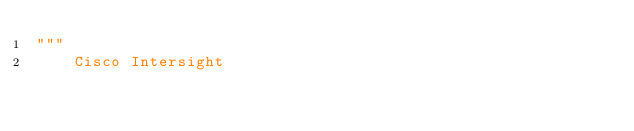<code> <loc_0><loc_0><loc_500><loc_500><_Python_>"""
    Cisco Intersight
</code> 